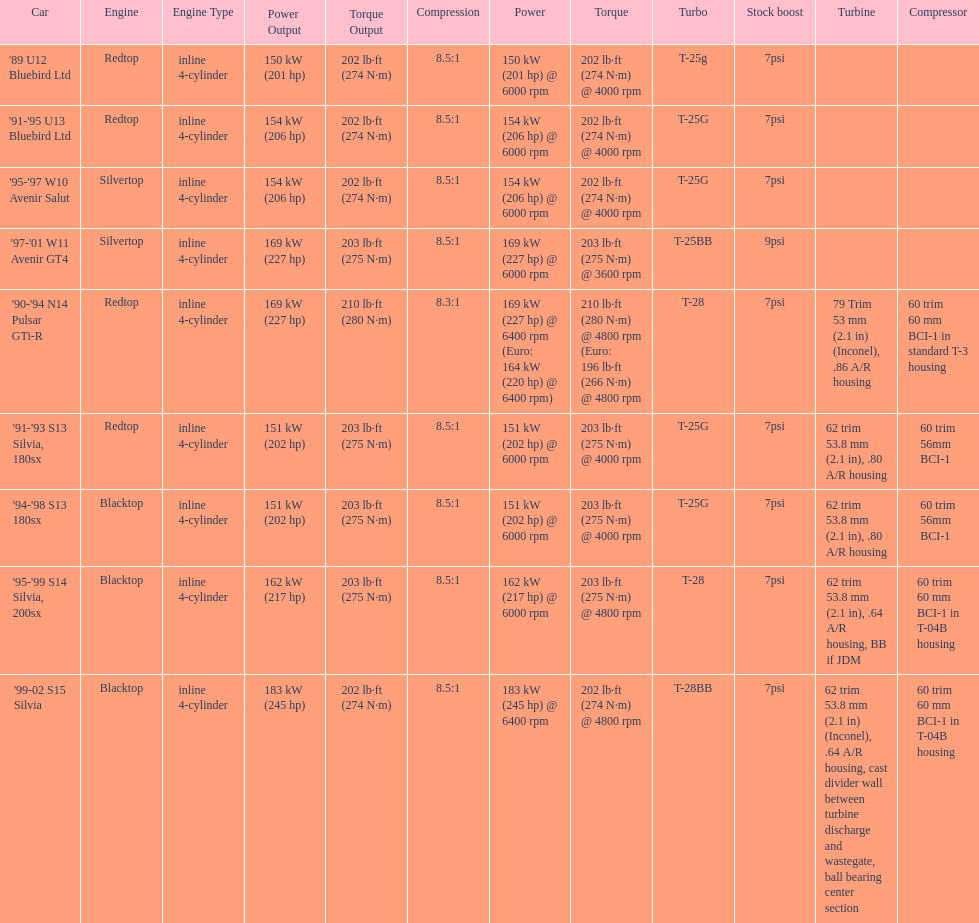How many models used the redtop engine? 4. 